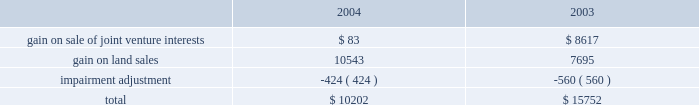Management 2019s discussion and analysis of financial condition and results of operations maturity at an effective rate of 6.33% ( 6.33 % ) .
In december we issued $ 250 million of unsecured floating rate debt at 26 basis points over libor .
The debt matures in two years , but is callable at our option after six months .
25cf in august , we paid off $ 15 million of a $ 40 million secured floating rate term loan .
We also assumed $ 29.9 million of secured debt in conjunction with a property acquisition in atlanta .
25cf the average balance and average borrowing rate of our $ 500 million revolving credit facility were slightly higher in 2004 than in 2003 .
At the end of 2004 we were not utilizing our credit facility .
Depreciation and amortization expense depreciation and amortization expense increased from $ 188.0 million in 2003 to $ 224.6 million in 2004 as a result of increased capital spending associated with increased leasing , the additional basis resulting from acquisitions , development activity and the application of sfas 141 as described below .
The points below highlight the significant increase in depreciation and amortization .
25cf depreciation expense on tenant improvements increased by $ 14.1 million .
25cf depreciation expense on buildings increased by $ 6.0 million .
25cf lease commission amortization increased by $ 2.2 million .
The amortization expense associated with acquired lease intangible assets increased by approximately $ 10.0 million .
The acquisitions were accounted for in accordance with sfas 141 which requires the allocation of a portion of a property 2019s purchase price to intangible assets for leases acquired and in-place at the closing date of the acquisition .
These intangible assets are amortized over the remaining life of the leases ( generally 3-5 years ) as compared to the building basis portion of the acquisition , which is depreciated over 40 years .
Service operations service operations primarily consist of our merchant building sales and the leasing , management , construction and development services for joint venture properties and properties owned by third parties .
These operations are heavily influenced by the current state of the economy as leasing and management fees are dependent upon occupancy while construction and development services rely on businesses expanding operations .
Service operations earnings increased from $ 21.8 million in 2003 to $ 24.4 million in 2004 .
The increase reflects higher construction volumes partially offset by increased staffing costs for our new national development and construction group and construction jobs in certain markets .
Other factors impacting service operations are discussed below .
25cf we experienced a 1.6% ( 1.6 % ) decrease in our overall gross profit margin percentage in our general contractor business in 2004 as compared to 2003 , due to continued competitive pricing pressure in many of our markets .
We expect margins to increase in 2005 as economic conditions improve .
However , despite this decrease , we were able to increase our net general contractor revenues from $ 26.8 million in 2003 to $ 27.6 million in 2004 because of an increase in volume .
This volume increase was attributable to continued low financing costs available to businesses , thereby making it more attractive for them to own instead of lease facilities .
We have a substantial backlog of $ 183.2 million for third party construction as of december 31 , 2004 , that will carry into 2005 .
25cf our merchant building development and sales program , whereby a building is developed by us and then sold , is a significant component of construction and development income .
During 2004 , we generated after tax gains of $ 16.5 million from the sale of six properties compared to $ 9.6 million from the sale of four properties in 2003 .
Profit margins on these types of building sales fluctuate by sale depending on the type of property being sold , the strength of the underlying tenant and nature of the sale , such as a pre-contracted purchase price for a primary tenant versus a sale on the open market .
General and administrative expense general and administrative expense increased from $ 22.1 million in 2003 to $ 26.4 million in 2004 .
The increase was a result of increased staffing and employee compensation costs to support development of our national development and construction group .
We also experienced an increase in marketing to support certain new projects .
Other income and expenses earnings from sales of land and ownership interests in unconsolidated companies , net of impairment adjustments , is comprised of the following amounts in 2004 and 2003 ( in thousands ) : .
In the first quarter of 2003 , we sold our 50% ( 50 % ) interest in a joint venture that owned and operated depreciable investment property .
The joint venture developed and operated real estate assets ; thus , the gain was not included in operating income. .
In 2004 what was the amount of the total gains on sales of the joint venture and the land? 
Computations: (10543 / 83)
Answer: 127.0241. 